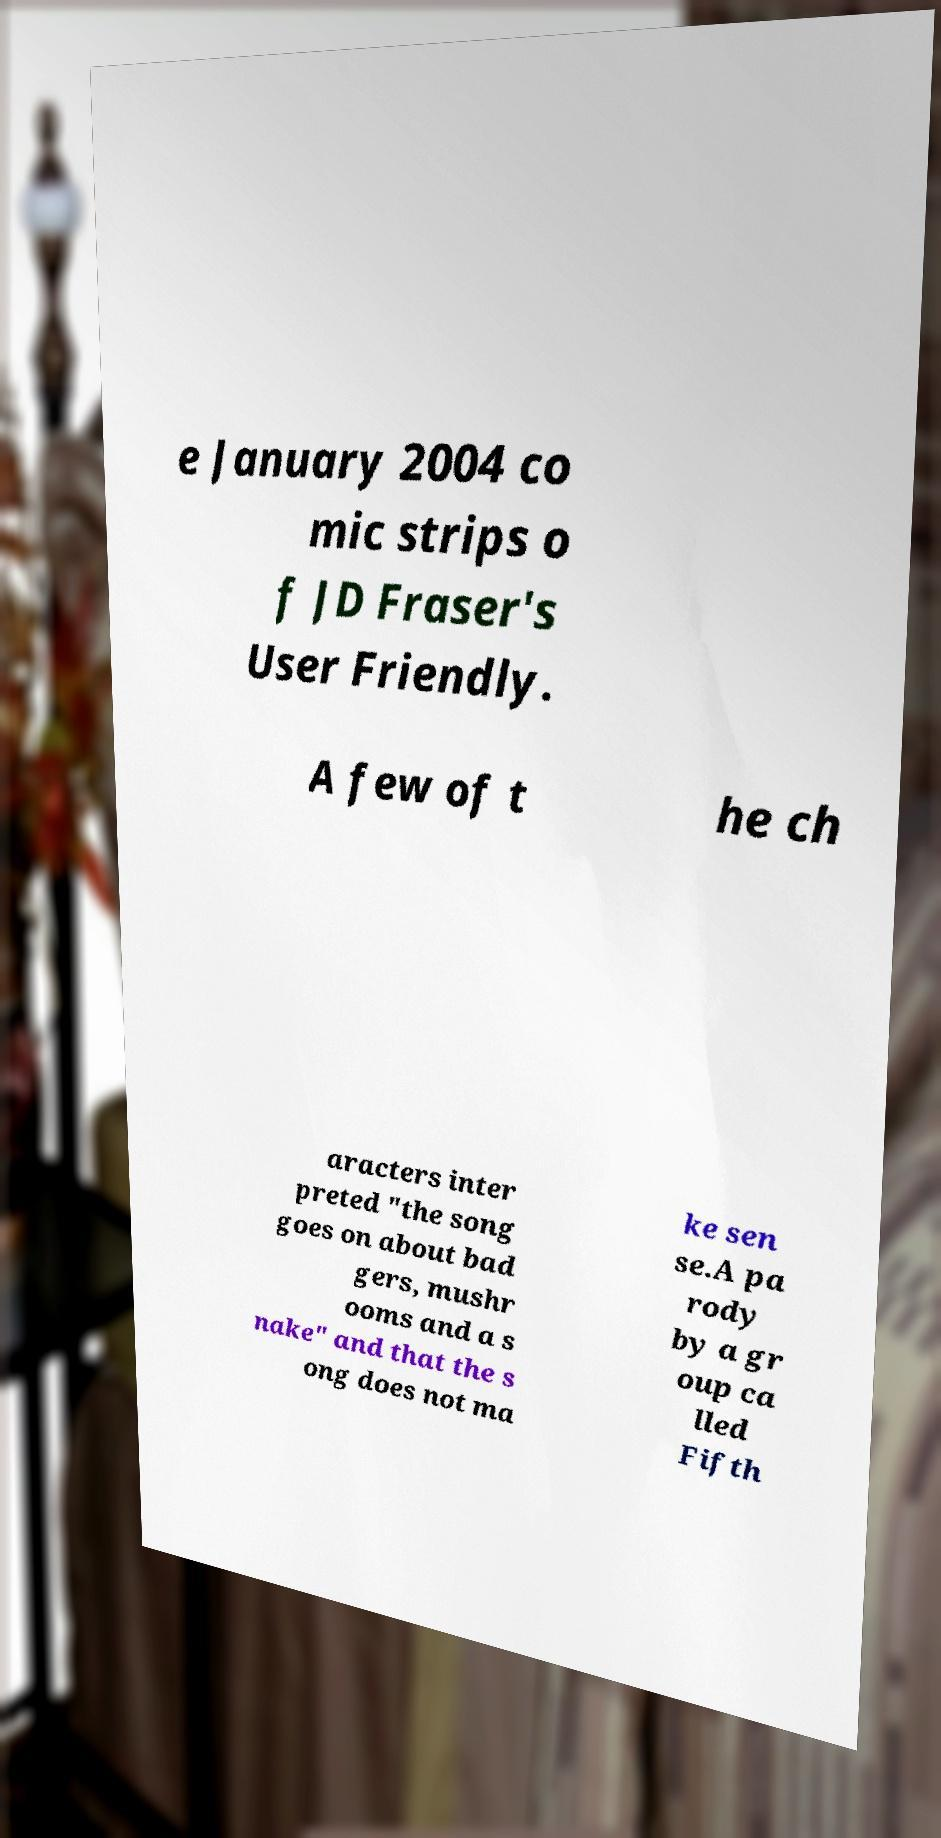I need the written content from this picture converted into text. Can you do that? e January 2004 co mic strips o f JD Fraser's User Friendly. A few of t he ch aracters inter preted "the song goes on about bad gers, mushr ooms and a s nake" and that the s ong does not ma ke sen se.A pa rody by a gr oup ca lled Fifth 